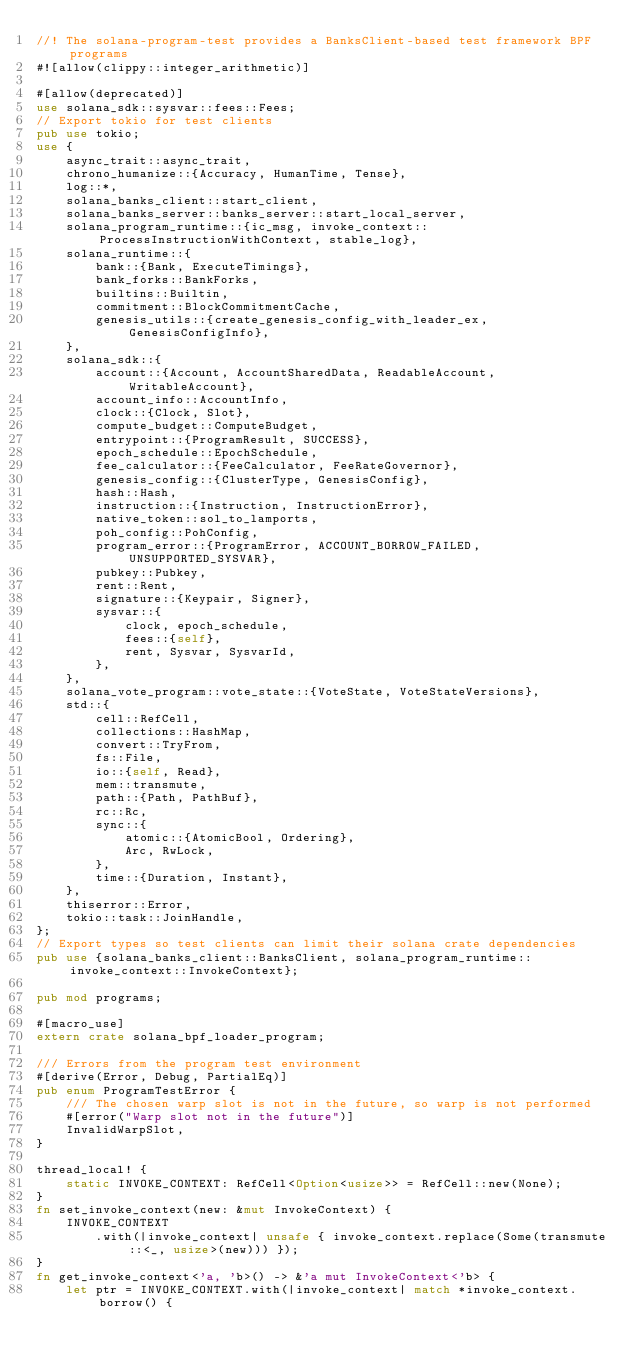<code> <loc_0><loc_0><loc_500><loc_500><_Rust_>//! The solana-program-test provides a BanksClient-based test framework BPF programs
#![allow(clippy::integer_arithmetic)]

#[allow(deprecated)]
use solana_sdk::sysvar::fees::Fees;
// Export tokio for test clients
pub use tokio;
use {
    async_trait::async_trait,
    chrono_humanize::{Accuracy, HumanTime, Tense},
    log::*,
    solana_banks_client::start_client,
    solana_banks_server::banks_server::start_local_server,
    solana_program_runtime::{ic_msg, invoke_context::ProcessInstructionWithContext, stable_log},
    solana_runtime::{
        bank::{Bank, ExecuteTimings},
        bank_forks::BankForks,
        builtins::Builtin,
        commitment::BlockCommitmentCache,
        genesis_utils::{create_genesis_config_with_leader_ex, GenesisConfigInfo},
    },
    solana_sdk::{
        account::{Account, AccountSharedData, ReadableAccount, WritableAccount},
        account_info::AccountInfo,
        clock::{Clock, Slot},
        compute_budget::ComputeBudget,
        entrypoint::{ProgramResult, SUCCESS},
        epoch_schedule::EpochSchedule,
        fee_calculator::{FeeCalculator, FeeRateGovernor},
        genesis_config::{ClusterType, GenesisConfig},
        hash::Hash,
        instruction::{Instruction, InstructionError},
        native_token::sol_to_lamports,
        poh_config::PohConfig,
        program_error::{ProgramError, ACCOUNT_BORROW_FAILED, UNSUPPORTED_SYSVAR},
        pubkey::Pubkey,
        rent::Rent,
        signature::{Keypair, Signer},
        sysvar::{
            clock, epoch_schedule,
            fees::{self},
            rent, Sysvar, SysvarId,
        },
    },
    solana_vote_program::vote_state::{VoteState, VoteStateVersions},
    std::{
        cell::RefCell,
        collections::HashMap,
        convert::TryFrom,
        fs::File,
        io::{self, Read},
        mem::transmute,
        path::{Path, PathBuf},
        rc::Rc,
        sync::{
            atomic::{AtomicBool, Ordering},
            Arc, RwLock,
        },
        time::{Duration, Instant},
    },
    thiserror::Error,
    tokio::task::JoinHandle,
};
// Export types so test clients can limit their solana crate dependencies
pub use {solana_banks_client::BanksClient, solana_program_runtime::invoke_context::InvokeContext};

pub mod programs;

#[macro_use]
extern crate solana_bpf_loader_program;

/// Errors from the program test environment
#[derive(Error, Debug, PartialEq)]
pub enum ProgramTestError {
    /// The chosen warp slot is not in the future, so warp is not performed
    #[error("Warp slot not in the future")]
    InvalidWarpSlot,
}

thread_local! {
    static INVOKE_CONTEXT: RefCell<Option<usize>> = RefCell::new(None);
}
fn set_invoke_context(new: &mut InvokeContext) {
    INVOKE_CONTEXT
        .with(|invoke_context| unsafe { invoke_context.replace(Some(transmute::<_, usize>(new))) });
}
fn get_invoke_context<'a, 'b>() -> &'a mut InvokeContext<'b> {
    let ptr = INVOKE_CONTEXT.with(|invoke_context| match *invoke_context.borrow() {</code> 